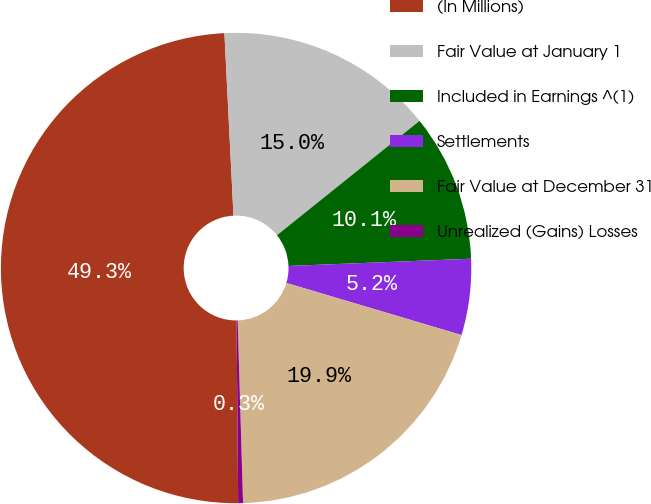<chart> <loc_0><loc_0><loc_500><loc_500><pie_chart><fcel>(In Millions)<fcel>Fair Value at January 1<fcel>Included in Earnings ^(1)<fcel>Settlements<fcel>Fair Value at December 31<fcel>Unrealized (Gains) Losses<nl><fcel>49.35%<fcel>15.03%<fcel>10.13%<fcel>5.23%<fcel>19.93%<fcel>0.33%<nl></chart> 